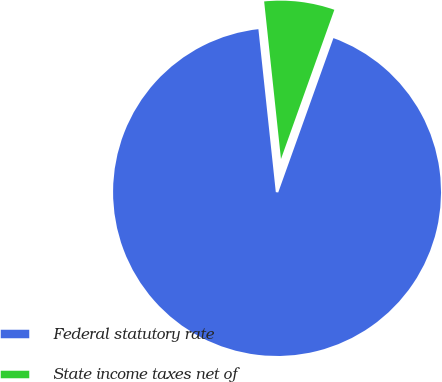Convert chart. <chart><loc_0><loc_0><loc_500><loc_500><pie_chart><fcel>Federal statutory rate<fcel>State income taxes net of<nl><fcel>92.84%<fcel>7.16%<nl></chart> 